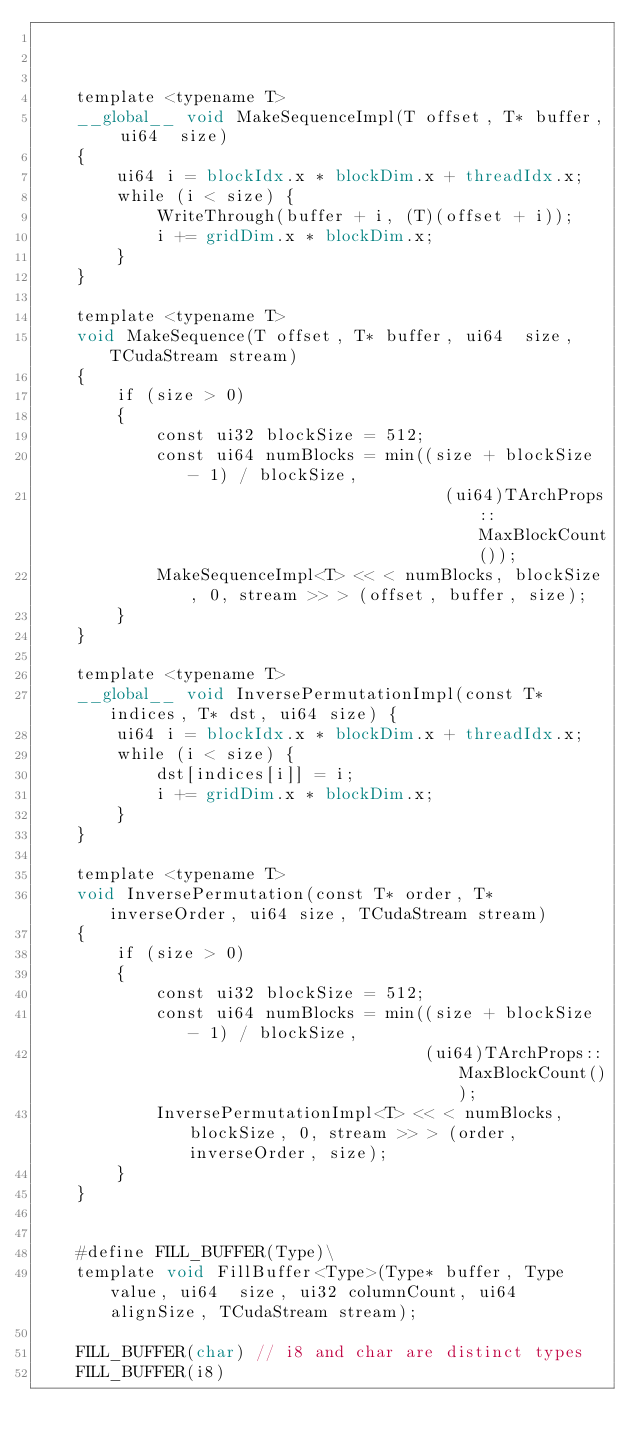<code> <loc_0><loc_0><loc_500><loc_500><_Cuda_>


    template <typename T>
    __global__ void MakeSequenceImpl(T offset, T* buffer, ui64  size)
    {
        ui64 i = blockIdx.x * blockDim.x + threadIdx.x;
        while (i < size) {
            WriteThrough(buffer + i, (T)(offset + i));
            i += gridDim.x * blockDim.x;
        }
    }

    template <typename T>
    void MakeSequence(T offset, T* buffer, ui64  size, TCudaStream stream)
    {
        if (size > 0)
        {
            const ui32 blockSize = 512;
            const ui64 numBlocks = min((size + blockSize - 1) / blockSize,
                                         (ui64)TArchProps::MaxBlockCount());
            MakeSequenceImpl<T> << < numBlocks, blockSize, 0, stream >> > (offset, buffer, size);
        }
    }

    template <typename T>
    __global__ void InversePermutationImpl(const T* indices, T* dst, ui64 size) {
        ui64 i = blockIdx.x * blockDim.x + threadIdx.x;
        while (i < size) {
            dst[indices[i]] = i;
            i += gridDim.x * blockDim.x;
        }
    }

    template <typename T>
    void InversePermutation(const T* order, T* inverseOrder, ui64 size, TCudaStream stream)
    {
        if (size > 0)
        {
            const ui32 blockSize = 512;
            const ui64 numBlocks = min((size + blockSize - 1) / blockSize,
                                       (ui64)TArchProps::MaxBlockCount());
            InversePermutationImpl<T> << < numBlocks, blockSize, 0, stream >> > (order, inverseOrder, size);
        }
    }


    #define FILL_BUFFER(Type)\
    template void FillBuffer<Type>(Type* buffer, Type value, ui64  size, ui32 columnCount, ui64 alignSize, TCudaStream stream);

    FILL_BUFFER(char) // i8 and char are distinct types
    FILL_BUFFER(i8)</code> 